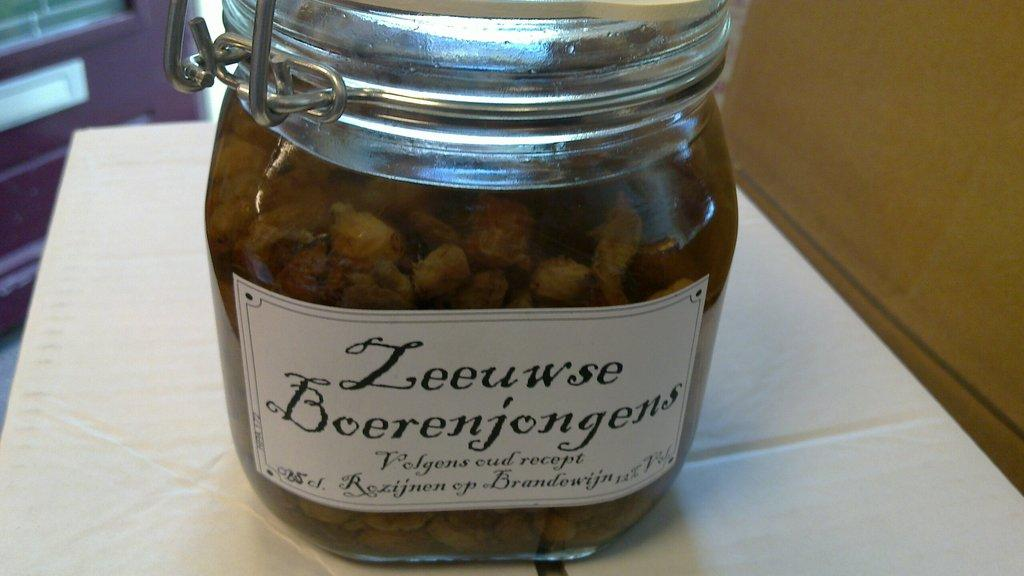<image>
Summarize the visual content of the image. a jar of Zeeuswe Boerenjongens filled to the brim 